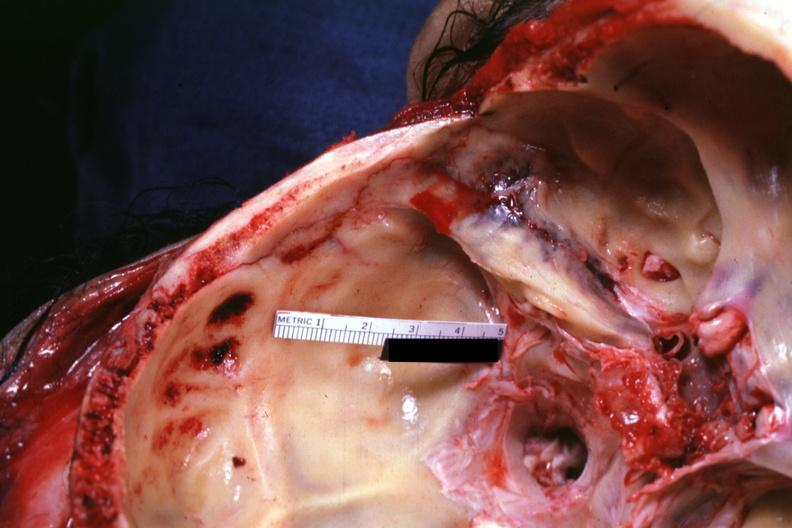what is present?
Answer the question using a single word or phrase. Bone 